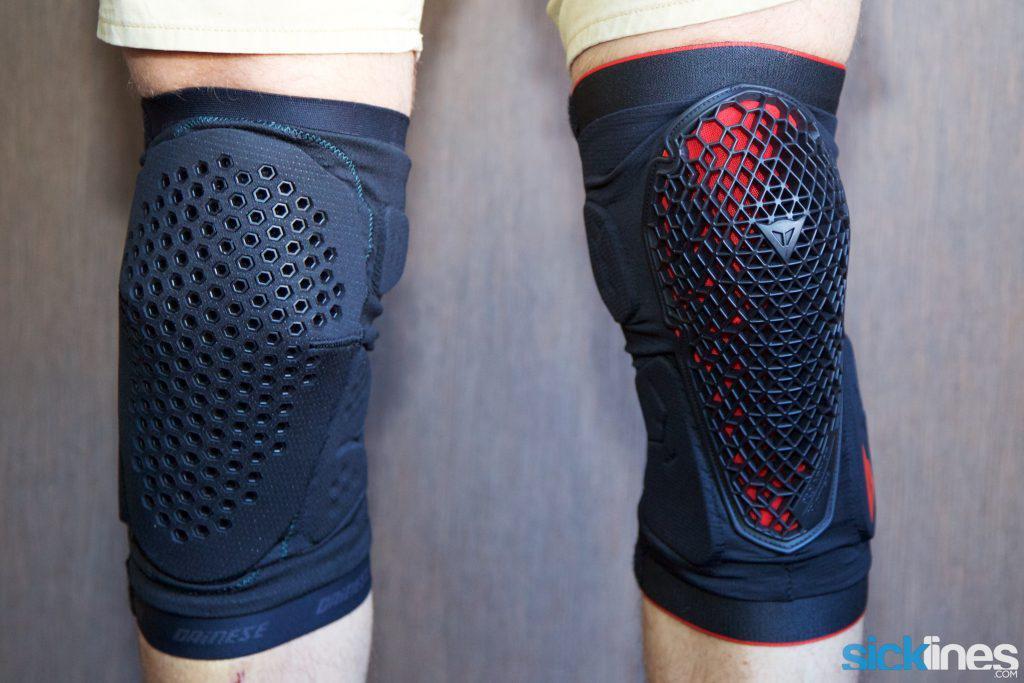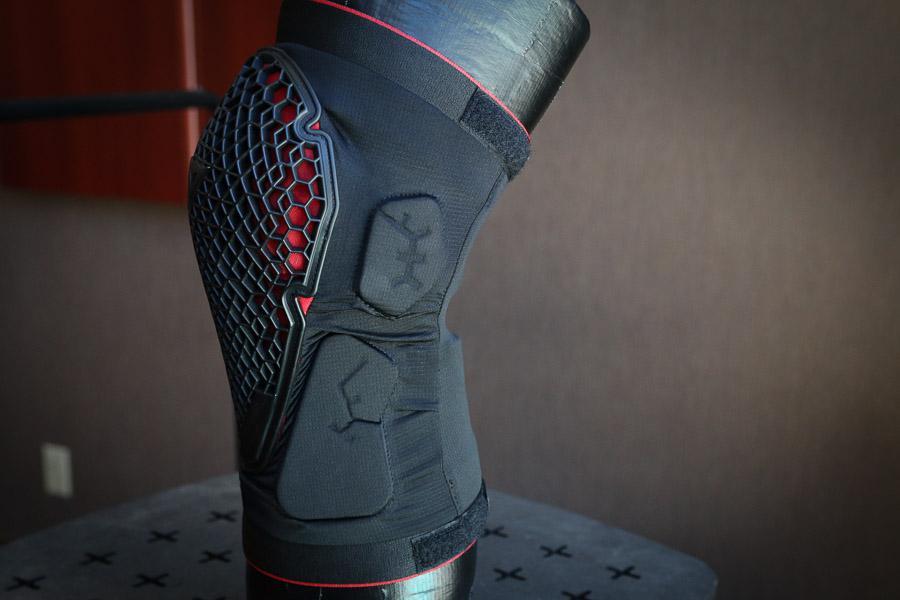The first image is the image on the left, the second image is the image on the right. Assess this claim about the two images: "In one image, a person is wearing a pair of knee pads with shorts, while the second image is one knee pad displayed on a model leg.". Correct or not? Answer yes or no. Yes. The first image is the image on the left, the second image is the image on the right. Given the left and right images, does the statement "A person is wearing two knee braces in the image on the left." hold true? Answer yes or no. Yes. 